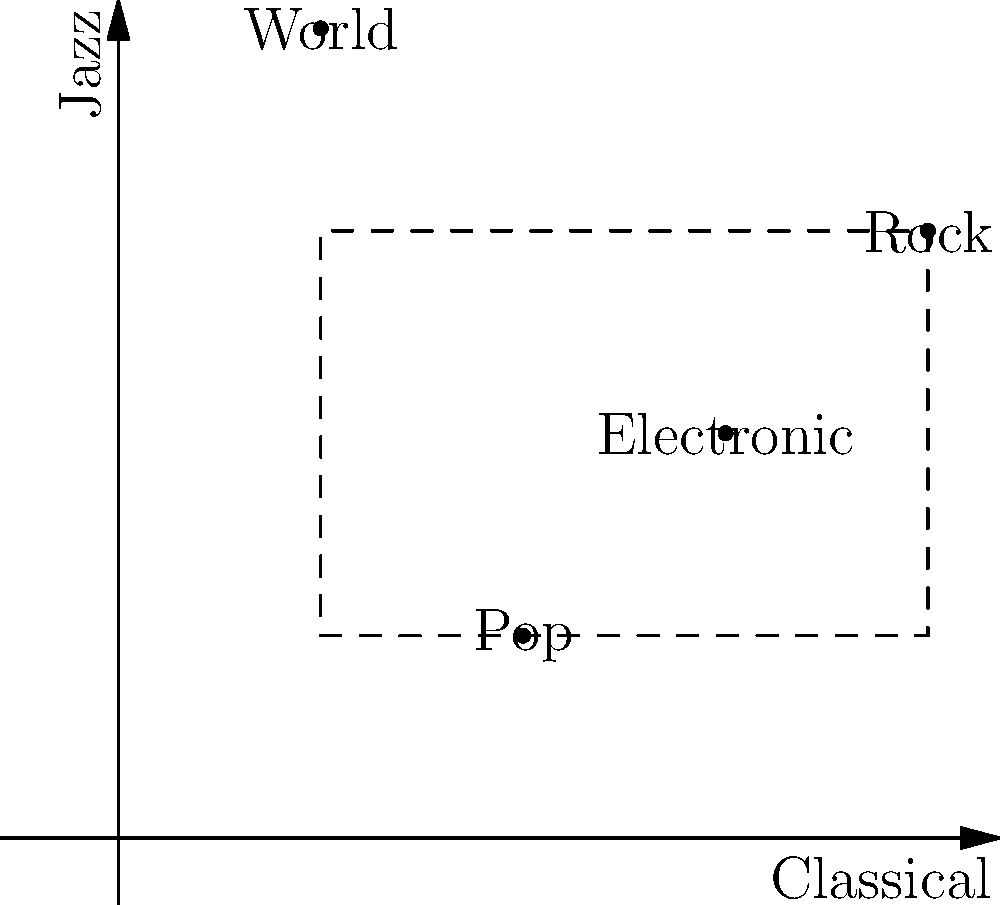In a musical genre chart, different genres are represented by coordinates on a plane where the x-axis represents Classical influence and the y-axis represents Jazz influence. Pop is at (2,1), Rock at (4,3), World Music at (1,4), and Electronic at (3,2). If we form a rectangle using Pop and Rock as opposite corners, what is the area of this rectangle in square units? To find the area of the rectangle, we need to follow these steps:

1. Identify the coordinates of the opposite corners:
   Pop: (2,1)
   Rock: (4,3)

2. Calculate the length of the rectangle:
   Length = $|x_2 - x_1| = |4 - 2| = 2$ units

3. Calculate the width of the rectangle:
   Width = $|y_2 - y_1| = |3 - 1| = 2$ units

4. Calculate the area using the formula:
   Area = Length × Width
   Area = $2 \times 2 = 4$ square units

Therefore, the area of the rectangle formed by Pop and Rock as opposite corners is 4 square units.
Answer: 4 square units 